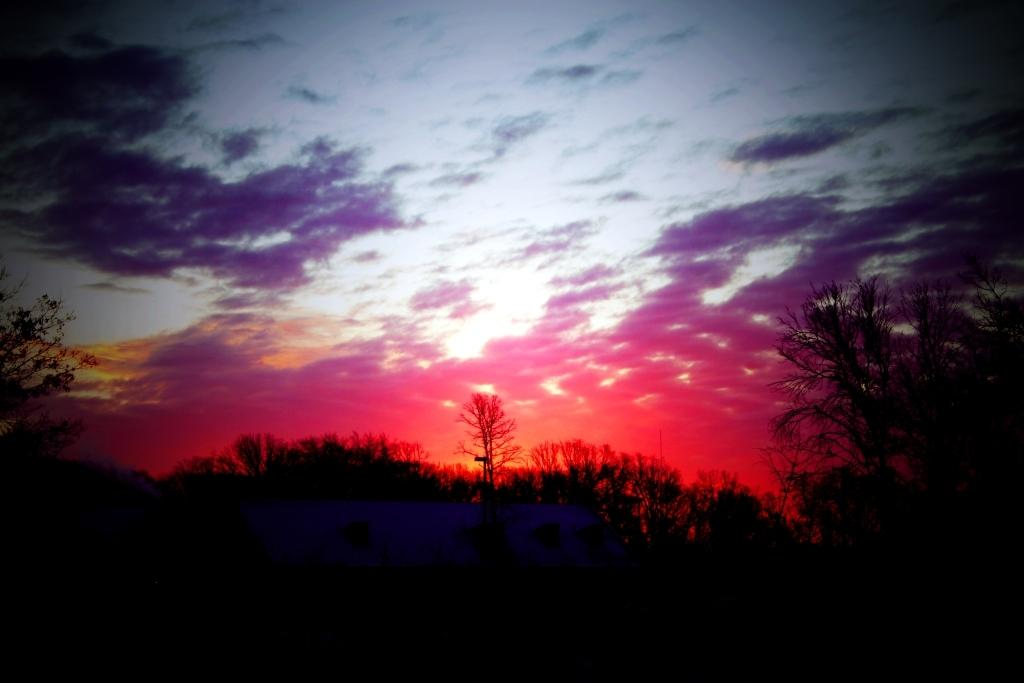What type of vegetation can be seen in the image? There are trees in the image. What part of the natural environment is visible in the image? The sky is visible in the image. What can be observed in the sky? Clouds are present in the sky. What type of sign can be seen on the trees in the image? There are no signs present on the trees in the image. What wheel-like object is visible in the image? There are no wheel-like objects present in the image. 